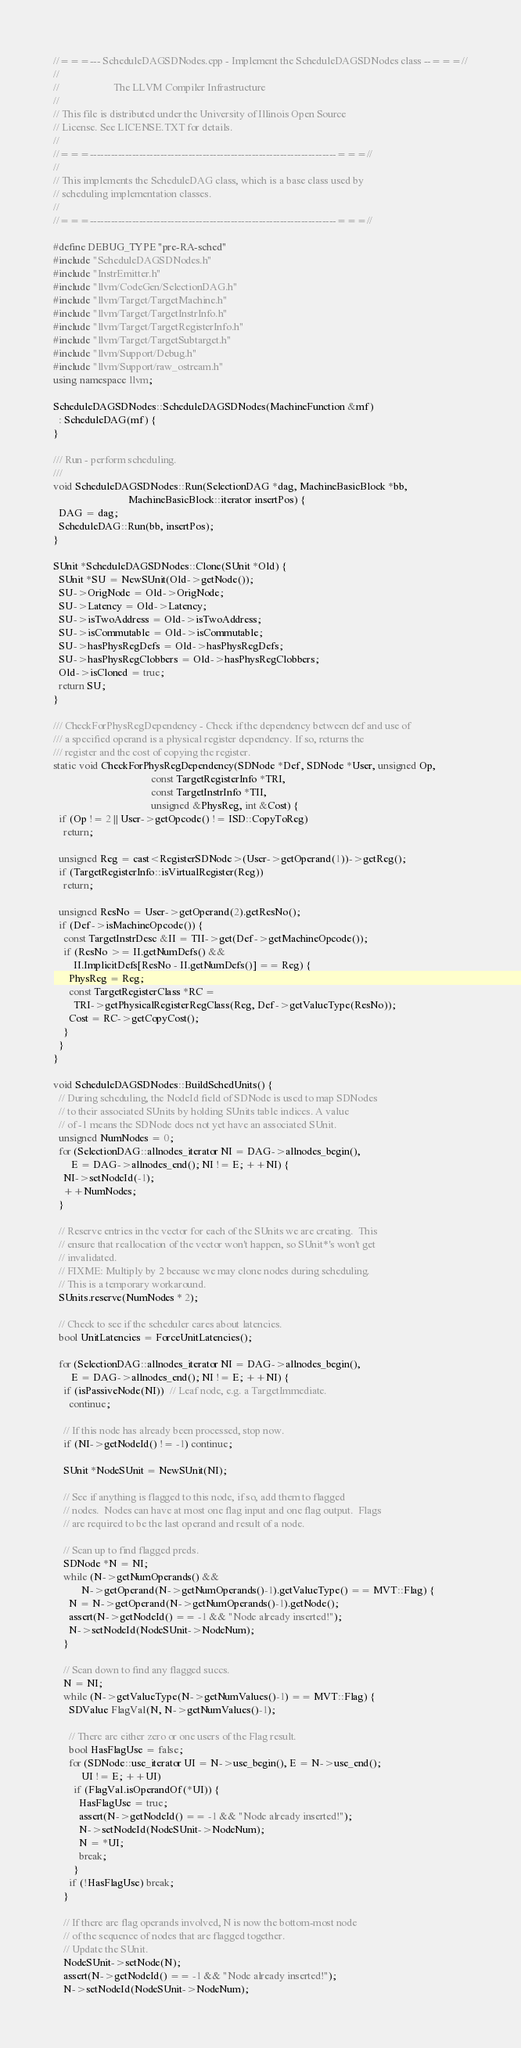<code> <loc_0><loc_0><loc_500><loc_500><_C++_>//===--- ScheduleDAGSDNodes.cpp - Implement the ScheduleDAGSDNodes class --===//
//
//                     The LLVM Compiler Infrastructure
//
// This file is distributed under the University of Illinois Open Source
// License. See LICENSE.TXT for details.
//
//===----------------------------------------------------------------------===//
//
// This implements the ScheduleDAG class, which is a base class used by
// scheduling implementation classes.
//
//===----------------------------------------------------------------------===//

#define DEBUG_TYPE "pre-RA-sched"
#include "ScheduleDAGSDNodes.h"
#include "InstrEmitter.h"
#include "llvm/CodeGen/SelectionDAG.h"
#include "llvm/Target/TargetMachine.h"
#include "llvm/Target/TargetInstrInfo.h"
#include "llvm/Target/TargetRegisterInfo.h"
#include "llvm/Target/TargetSubtarget.h"
#include "llvm/Support/Debug.h"
#include "llvm/Support/raw_ostream.h"
using namespace llvm;

ScheduleDAGSDNodes::ScheduleDAGSDNodes(MachineFunction &mf)
  : ScheduleDAG(mf) {
}

/// Run - perform scheduling.
///
void ScheduleDAGSDNodes::Run(SelectionDAG *dag, MachineBasicBlock *bb,
                             MachineBasicBlock::iterator insertPos) {
  DAG = dag;
  ScheduleDAG::Run(bb, insertPos);
}

SUnit *ScheduleDAGSDNodes::Clone(SUnit *Old) {
  SUnit *SU = NewSUnit(Old->getNode());
  SU->OrigNode = Old->OrigNode;
  SU->Latency = Old->Latency;
  SU->isTwoAddress = Old->isTwoAddress;
  SU->isCommutable = Old->isCommutable;
  SU->hasPhysRegDefs = Old->hasPhysRegDefs;
  SU->hasPhysRegClobbers = Old->hasPhysRegClobbers;
  Old->isCloned = true;
  return SU;
}

/// CheckForPhysRegDependency - Check if the dependency between def and use of
/// a specified operand is a physical register dependency. If so, returns the
/// register and the cost of copying the register.
static void CheckForPhysRegDependency(SDNode *Def, SDNode *User, unsigned Op,
                                      const TargetRegisterInfo *TRI, 
                                      const TargetInstrInfo *TII,
                                      unsigned &PhysReg, int &Cost) {
  if (Op != 2 || User->getOpcode() != ISD::CopyToReg)
    return;

  unsigned Reg = cast<RegisterSDNode>(User->getOperand(1))->getReg();
  if (TargetRegisterInfo::isVirtualRegister(Reg))
    return;

  unsigned ResNo = User->getOperand(2).getResNo();
  if (Def->isMachineOpcode()) {
    const TargetInstrDesc &II = TII->get(Def->getMachineOpcode());
    if (ResNo >= II.getNumDefs() &&
        II.ImplicitDefs[ResNo - II.getNumDefs()] == Reg) {
      PhysReg = Reg;
      const TargetRegisterClass *RC =
        TRI->getPhysicalRegisterRegClass(Reg, Def->getValueType(ResNo));
      Cost = RC->getCopyCost();
    }
  }
}

void ScheduleDAGSDNodes::BuildSchedUnits() {
  // During scheduling, the NodeId field of SDNode is used to map SDNodes
  // to their associated SUnits by holding SUnits table indices. A value
  // of -1 means the SDNode does not yet have an associated SUnit.
  unsigned NumNodes = 0;
  for (SelectionDAG::allnodes_iterator NI = DAG->allnodes_begin(),
       E = DAG->allnodes_end(); NI != E; ++NI) {
    NI->setNodeId(-1);
    ++NumNodes;
  }

  // Reserve entries in the vector for each of the SUnits we are creating.  This
  // ensure that reallocation of the vector won't happen, so SUnit*'s won't get
  // invalidated.
  // FIXME: Multiply by 2 because we may clone nodes during scheduling.
  // This is a temporary workaround.
  SUnits.reserve(NumNodes * 2);
  
  // Check to see if the scheduler cares about latencies.
  bool UnitLatencies = ForceUnitLatencies();

  for (SelectionDAG::allnodes_iterator NI = DAG->allnodes_begin(),
       E = DAG->allnodes_end(); NI != E; ++NI) {
    if (isPassiveNode(NI))  // Leaf node, e.g. a TargetImmediate.
      continue;
    
    // If this node has already been processed, stop now.
    if (NI->getNodeId() != -1) continue;
    
    SUnit *NodeSUnit = NewSUnit(NI);
    
    // See if anything is flagged to this node, if so, add them to flagged
    // nodes.  Nodes can have at most one flag input and one flag output.  Flags
    // are required to be the last operand and result of a node.
    
    // Scan up to find flagged preds.
    SDNode *N = NI;
    while (N->getNumOperands() &&
           N->getOperand(N->getNumOperands()-1).getValueType() == MVT::Flag) {
      N = N->getOperand(N->getNumOperands()-1).getNode();
      assert(N->getNodeId() == -1 && "Node already inserted!");
      N->setNodeId(NodeSUnit->NodeNum);
    }
    
    // Scan down to find any flagged succs.
    N = NI;
    while (N->getValueType(N->getNumValues()-1) == MVT::Flag) {
      SDValue FlagVal(N, N->getNumValues()-1);
      
      // There are either zero or one users of the Flag result.
      bool HasFlagUse = false;
      for (SDNode::use_iterator UI = N->use_begin(), E = N->use_end(); 
           UI != E; ++UI)
        if (FlagVal.isOperandOf(*UI)) {
          HasFlagUse = true;
          assert(N->getNodeId() == -1 && "Node already inserted!");
          N->setNodeId(NodeSUnit->NodeNum);
          N = *UI;
          break;
        }
      if (!HasFlagUse) break;
    }
    
    // If there are flag operands involved, N is now the bottom-most node
    // of the sequence of nodes that are flagged together.
    // Update the SUnit.
    NodeSUnit->setNode(N);
    assert(N->getNodeId() == -1 && "Node already inserted!");
    N->setNodeId(NodeSUnit->NodeNum);
</code> 